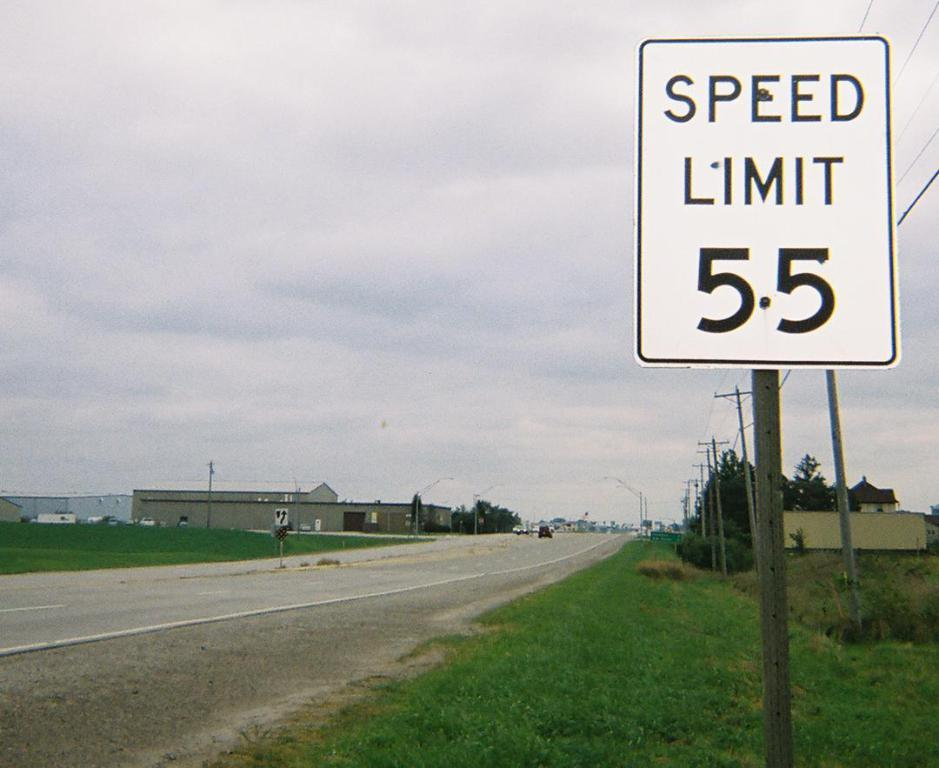<image>
Present a compact description of the photo's key features. a speed limit sign that has 55 on it 